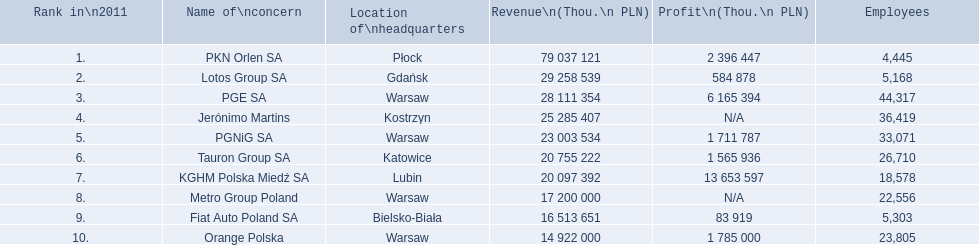What is the total of employees employed by pkn orlen sa in poland? 4,445. What total of employees work for lotos group sa? 5,168. How many staff members work for pgnig sa? 33,071. 